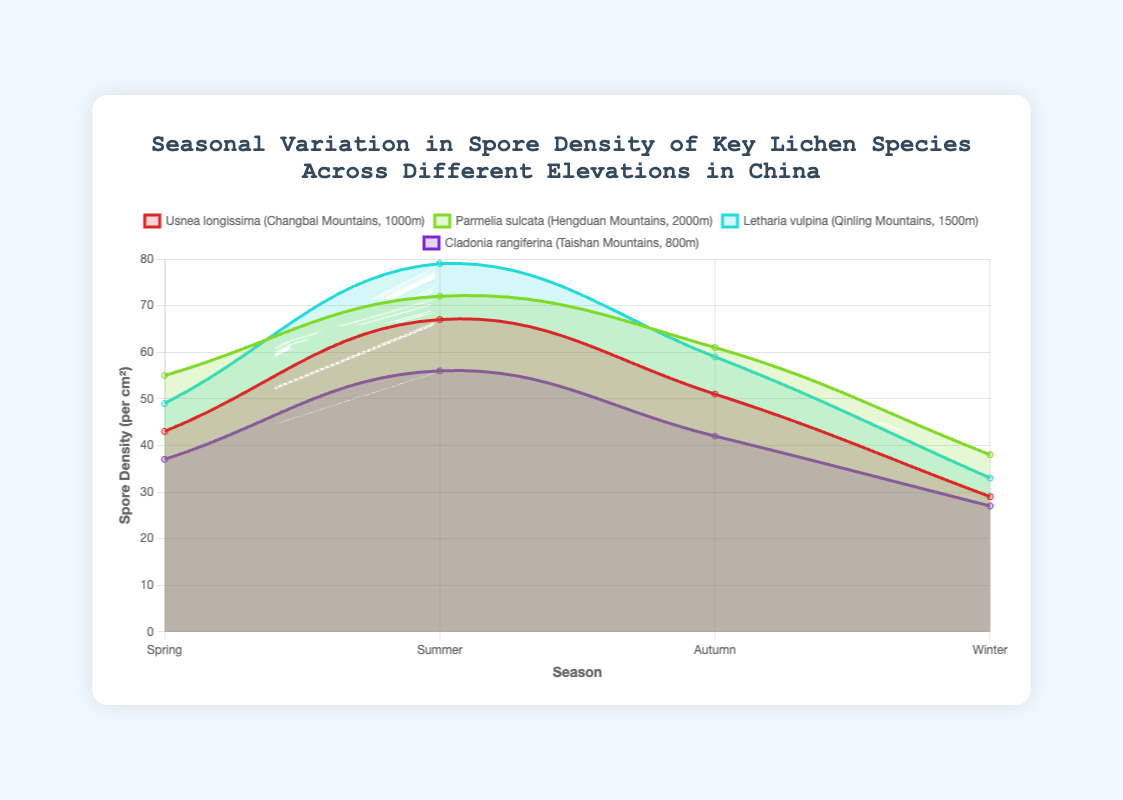Which lichen species has the highest spore density in the summer? To determine this, we look at the spore density values for all species in the summer season. Usnea longissima has 67 spores/cm², Parmelia sulcata has 72 spores/cm², Letharia vulpina has 79 spores/cm², and Cladonia rangiferina has 56 spores/cm². Letharia vulpina has the highest value.
Answer: Letharia vulpina What is the average spore density of Usnea longissima across all seasons? The spore density for Usnea longissima is 43 in spring, 67 in summer, 51 in autumn, and 29 in winter. The average is calculated as (43 + 67 + 51 + 29) / 4 = 47.5.
Answer: 47.5 Compare the difference in winter spore densities between Parmelia sulcata and Letharia vulpina. Look at the winter spore densities: Parmelia sulcata has 38 spores/cm² and Letharia vulpina has 33 spores/cm². The difference is 38 - 33 = 5.
Answer: 5 Which season sees the lowest spore density for Cladonia rangiferina? For Cladonia rangiferina, the spore densities are 37 in spring, 56 in summer, 42 in autumn, and 27 in winter. Winter has the lowest spore density.
Answer: Winter Determine the total spore density for Letharia vulpina in the Qinling Mountains over the year. Adding up the spore densities: 49 in spring, 79 in summer, 59 in autumn, and 33 in winter, we get a total of 49 + 79 + 59 + 33 = 220.
Answer: 220 Compare the variability of spore density between Usnea longissima and Cladonia rangiferina. Calculate the range (difference between highest and lowest values) for each species. Usnea longissima's range: 67 - 29 = 38. Cladonia rangiferina's range: 56 - 27 = 29. Usnea longissima has a higher variability in spore density.
Answer: Usnea longissima has higher variability In which species and season do we observe the maximum spore density? Review all spore density values across species and seasons: Usnea longissima (max 67 in summer), Parmelia sulcata (max 72 in summer), Letharia vulpina (max 79 in summer), Cladonia rangiferina (max 56 in summer). The maximum value is 79 seen in Letharia vulpina during summer.
Answer: Letharia vulpina, summer How much does the spore density for Parmelia sulcata increase from spring to summer? Spring spore density is 55 spores/cm² and summer is 72 spores/cm². The increase is calculated as 72 - 55 = 17.
Answer: 17 Which species shows the most significant drop in spore density from autumn to winter? Calculate the drop for each species: Usnea longissima (51 to 29, drop = 22), Parmelia sulcata (61 to 38, drop = 23), Letharia vulpina (59 to 33, drop = 26), Cladonia rangiferina (42 to 27, drop = 15). Letharia vulpina shows the most significant drop with a reduction of 26 spores/cm².
Answer: Letharia vulpina What is the proportion of summer spore density to winter spore density for Usnea longissima? For Usnea longissima, summer density is 67 and winter density is 29. The proportion is 67 / 29 ≈ 2.31.
Answer: 2.31 